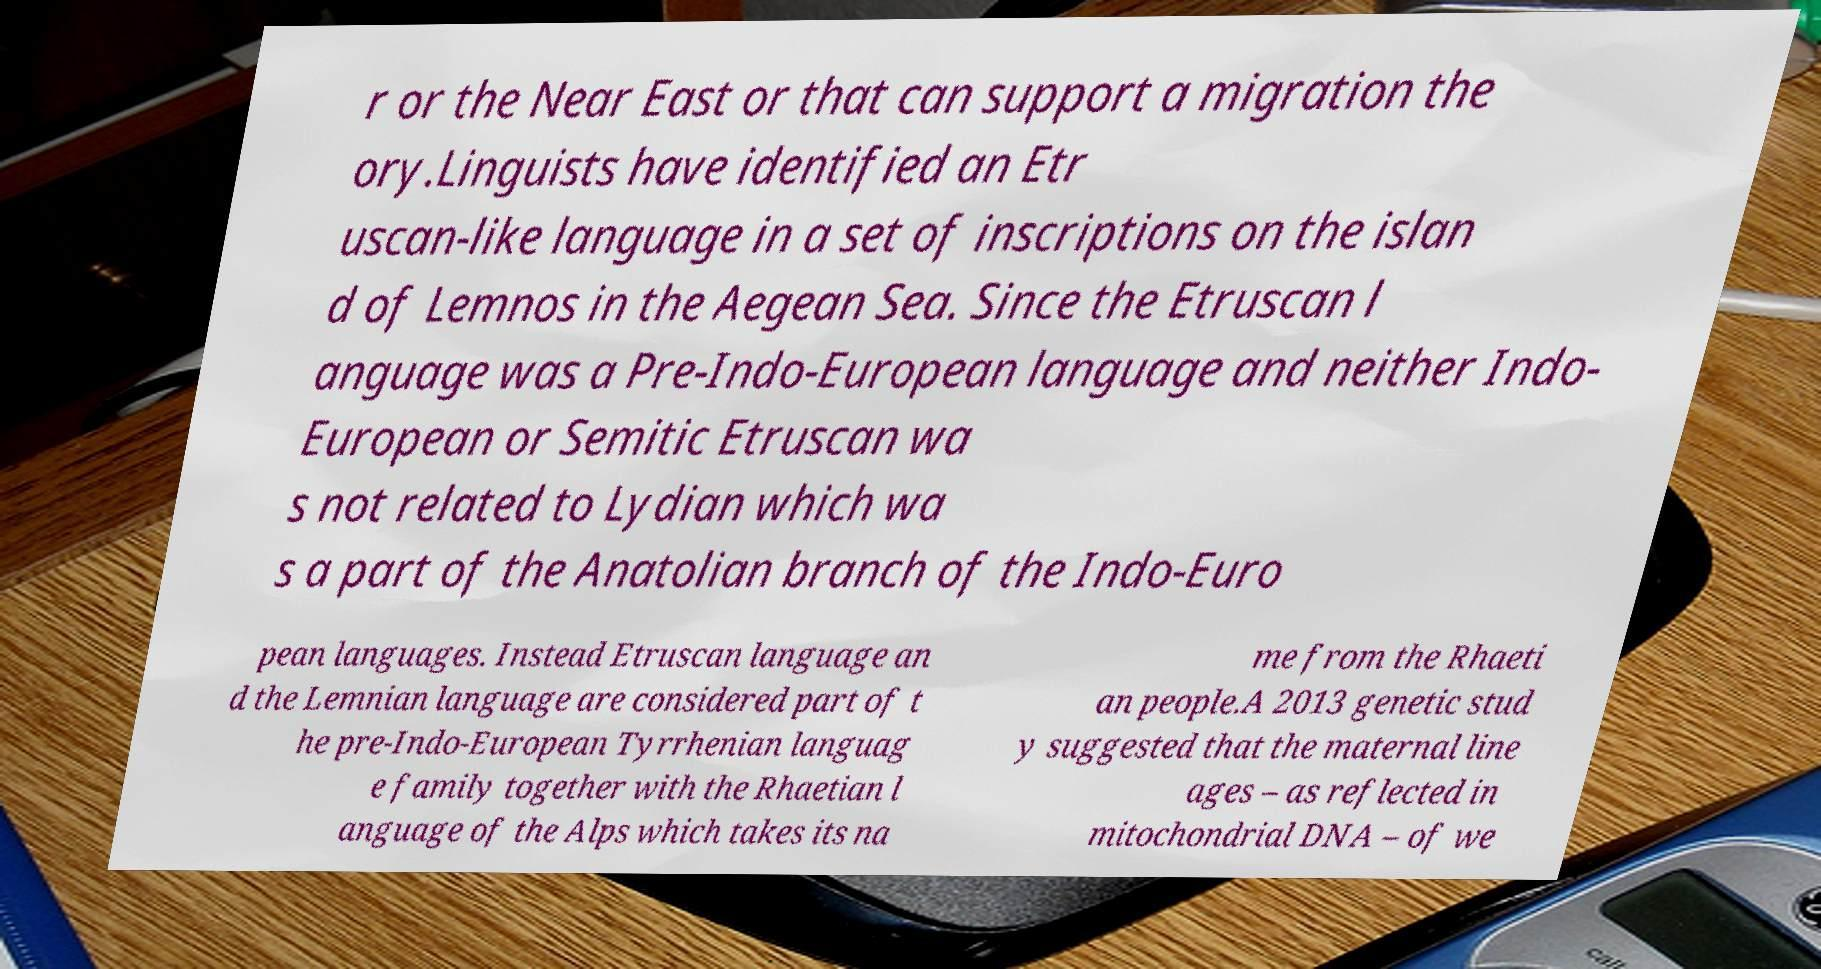Could you assist in decoding the text presented in this image and type it out clearly? r or the Near East or that can support a migration the ory.Linguists have identified an Etr uscan-like language in a set of inscriptions on the islan d of Lemnos in the Aegean Sea. Since the Etruscan l anguage was a Pre-Indo-European language and neither Indo- European or Semitic Etruscan wa s not related to Lydian which wa s a part of the Anatolian branch of the Indo-Euro pean languages. Instead Etruscan language an d the Lemnian language are considered part of t he pre-Indo-European Tyrrhenian languag e family together with the Rhaetian l anguage of the Alps which takes its na me from the Rhaeti an people.A 2013 genetic stud y suggested that the maternal line ages – as reflected in mitochondrial DNA – of we 